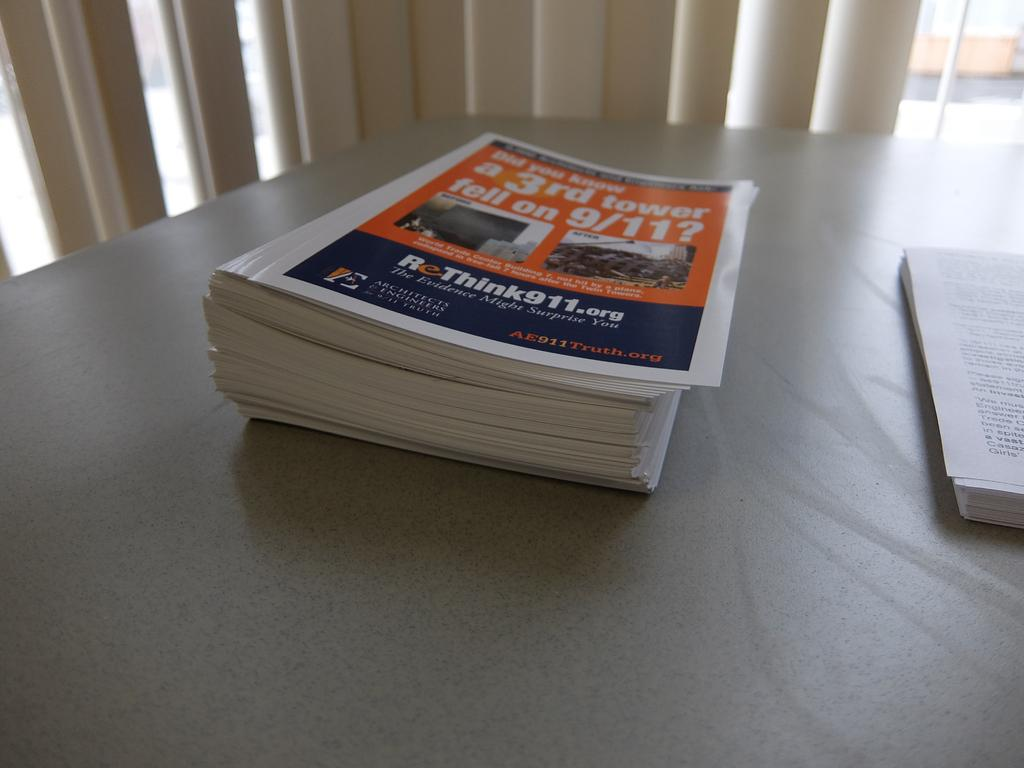<image>
Give a short and clear explanation of the subsequent image. A stack of magazines on the table has 9/11 on the cover. 